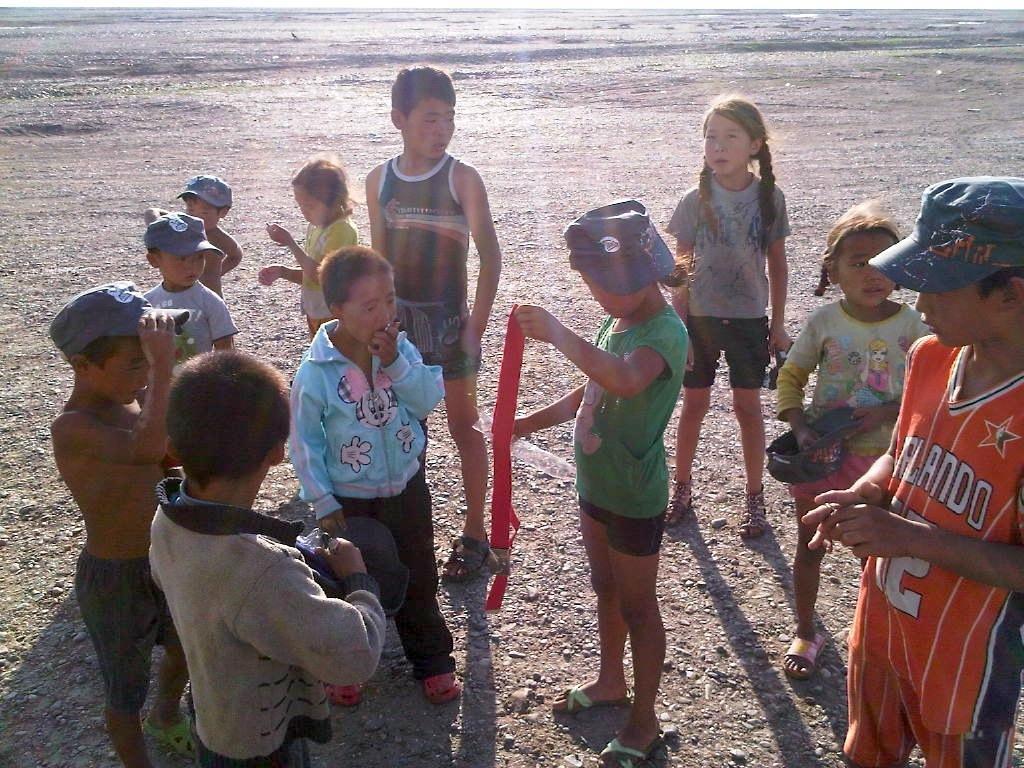Please provide a concise description of this image. This image consists of many children. They are standing near the beach. In the background, we can see the water. At the bottom, there is a land. In the middle, the girl is holding a red cloth. 